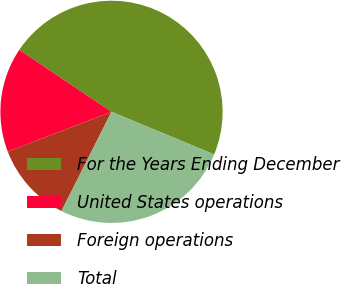<chart> <loc_0><loc_0><loc_500><loc_500><pie_chart><fcel>For the Years Ending December<fcel>United States operations<fcel>Foreign operations<fcel>Total<nl><fcel>46.85%<fcel>15.25%<fcel>11.74%<fcel>26.17%<nl></chart> 